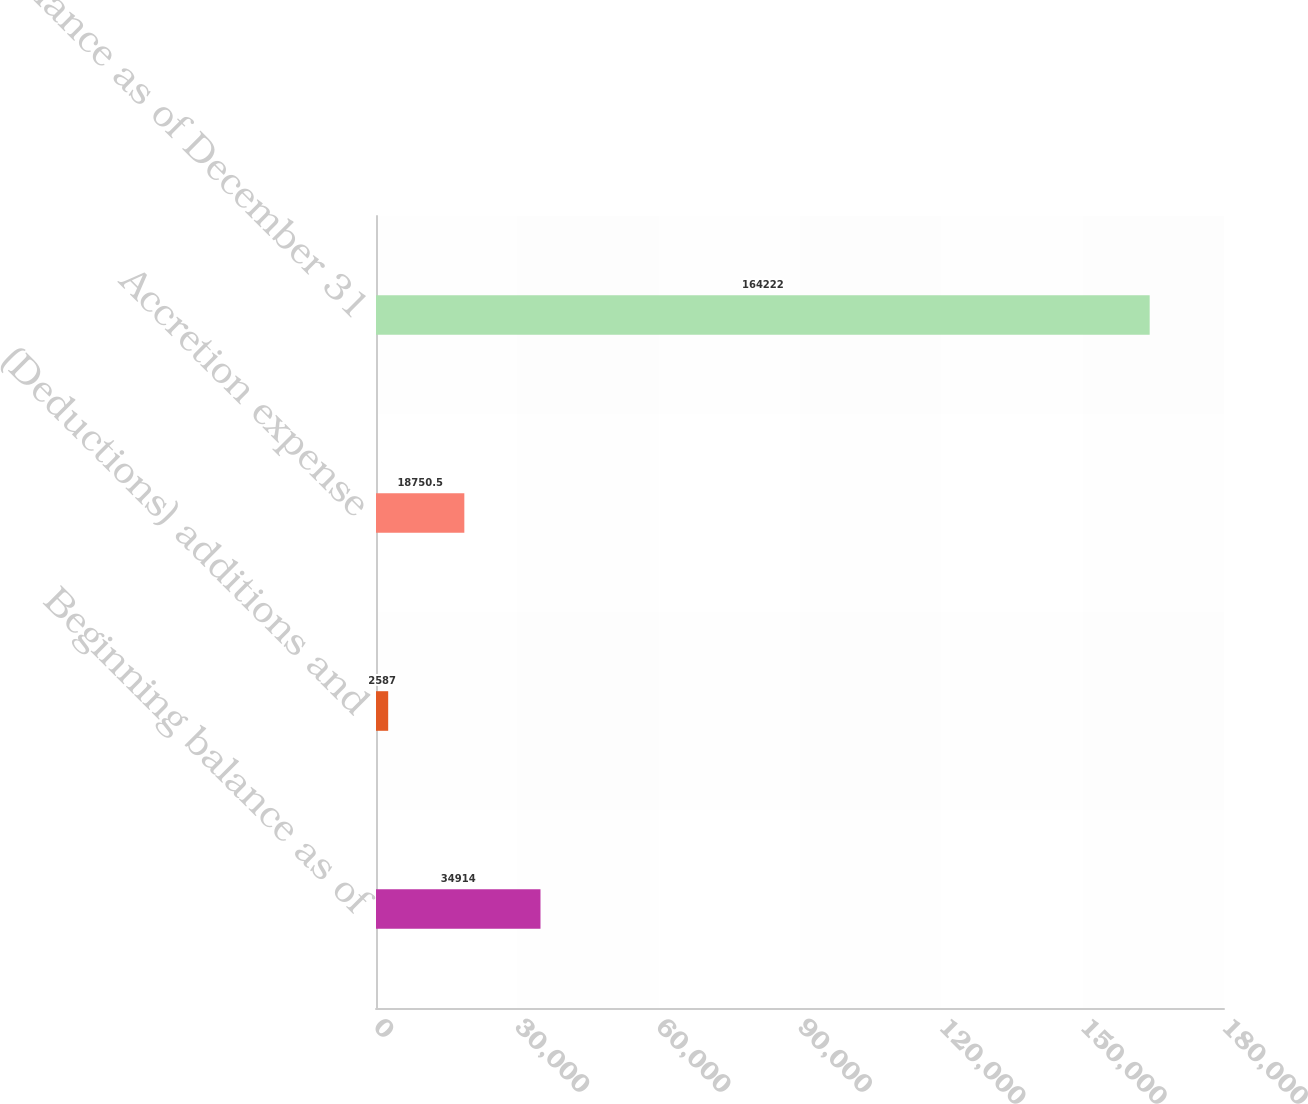Convert chart to OTSL. <chart><loc_0><loc_0><loc_500><loc_500><bar_chart><fcel>Beginning balance as of<fcel>(Deductions) additions and<fcel>Accretion expense<fcel>Balance as of December 31<nl><fcel>34914<fcel>2587<fcel>18750.5<fcel>164222<nl></chart> 